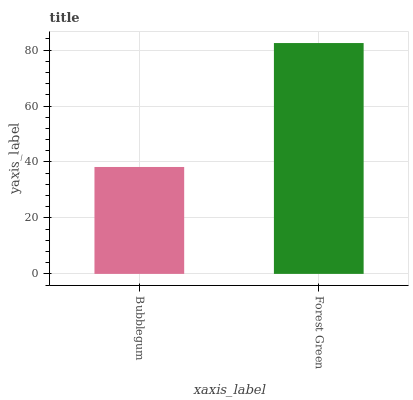Is Bubblegum the minimum?
Answer yes or no. Yes. Is Forest Green the maximum?
Answer yes or no. Yes. Is Forest Green the minimum?
Answer yes or no. No. Is Forest Green greater than Bubblegum?
Answer yes or no. Yes. Is Bubblegum less than Forest Green?
Answer yes or no. Yes. Is Bubblegum greater than Forest Green?
Answer yes or no. No. Is Forest Green less than Bubblegum?
Answer yes or no. No. Is Forest Green the high median?
Answer yes or no. Yes. Is Bubblegum the low median?
Answer yes or no. Yes. Is Bubblegum the high median?
Answer yes or no. No. Is Forest Green the low median?
Answer yes or no. No. 